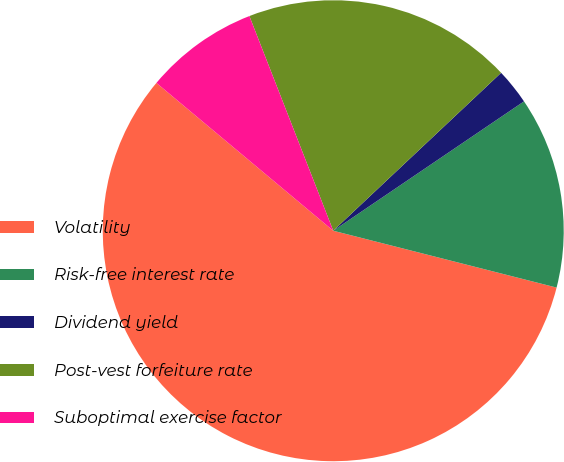<chart> <loc_0><loc_0><loc_500><loc_500><pie_chart><fcel>Volatility<fcel>Risk-free interest rate<fcel>Dividend yield<fcel>Post-vest forfeiture rate<fcel>Suboptimal exercise factor<nl><fcel>57.11%<fcel>13.45%<fcel>2.53%<fcel>18.91%<fcel>7.99%<nl></chart> 